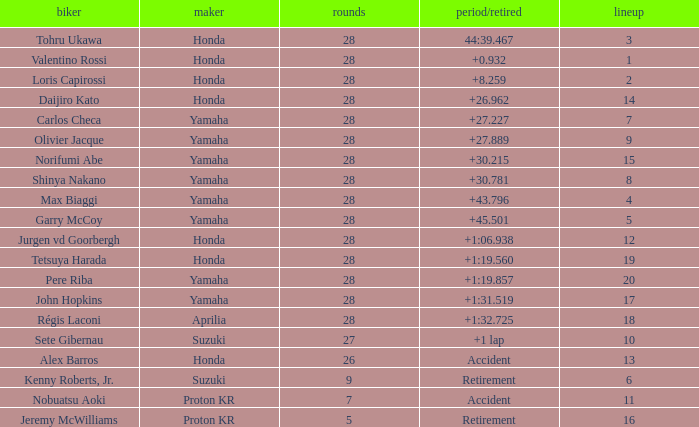How many laps were in grid 4? 28.0. I'm looking to parse the entire table for insights. Could you assist me with that? {'header': ['biker', 'maker', 'rounds', 'period/retired', 'lineup'], 'rows': [['Tohru Ukawa', 'Honda', '28', '44:39.467', '3'], ['Valentino Rossi', 'Honda', '28', '+0.932', '1'], ['Loris Capirossi', 'Honda', '28', '+8.259', '2'], ['Daijiro Kato', 'Honda', '28', '+26.962', '14'], ['Carlos Checa', 'Yamaha', '28', '+27.227', '7'], ['Olivier Jacque', 'Yamaha', '28', '+27.889', '9'], ['Norifumi Abe', 'Yamaha', '28', '+30.215', '15'], ['Shinya Nakano', 'Yamaha', '28', '+30.781', '8'], ['Max Biaggi', 'Yamaha', '28', '+43.796', '4'], ['Garry McCoy', 'Yamaha', '28', '+45.501', '5'], ['Jurgen vd Goorbergh', 'Honda', '28', '+1:06.938', '12'], ['Tetsuya Harada', 'Honda', '28', '+1:19.560', '19'], ['Pere Riba', 'Yamaha', '28', '+1:19.857', '20'], ['John Hopkins', 'Yamaha', '28', '+1:31.519', '17'], ['Régis Laconi', 'Aprilia', '28', '+1:32.725', '18'], ['Sete Gibernau', 'Suzuki', '27', '+1 lap', '10'], ['Alex Barros', 'Honda', '26', 'Accident', '13'], ['Kenny Roberts, Jr.', 'Suzuki', '9', 'Retirement', '6'], ['Nobuatsu Aoki', 'Proton KR', '7', 'Accident', '11'], ['Jeremy McWilliams', 'Proton KR', '5', 'Retirement', '16']]} 